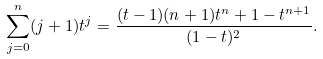Convert formula to latex. <formula><loc_0><loc_0><loc_500><loc_500>\sum _ { j = 0 } ^ { n } ( j + 1 ) t ^ { j } = \frac { ( t - 1 ) ( n + 1 ) t ^ { n } + 1 - t ^ { n + 1 } } { ( 1 - t ) ^ { 2 } } .</formula> 